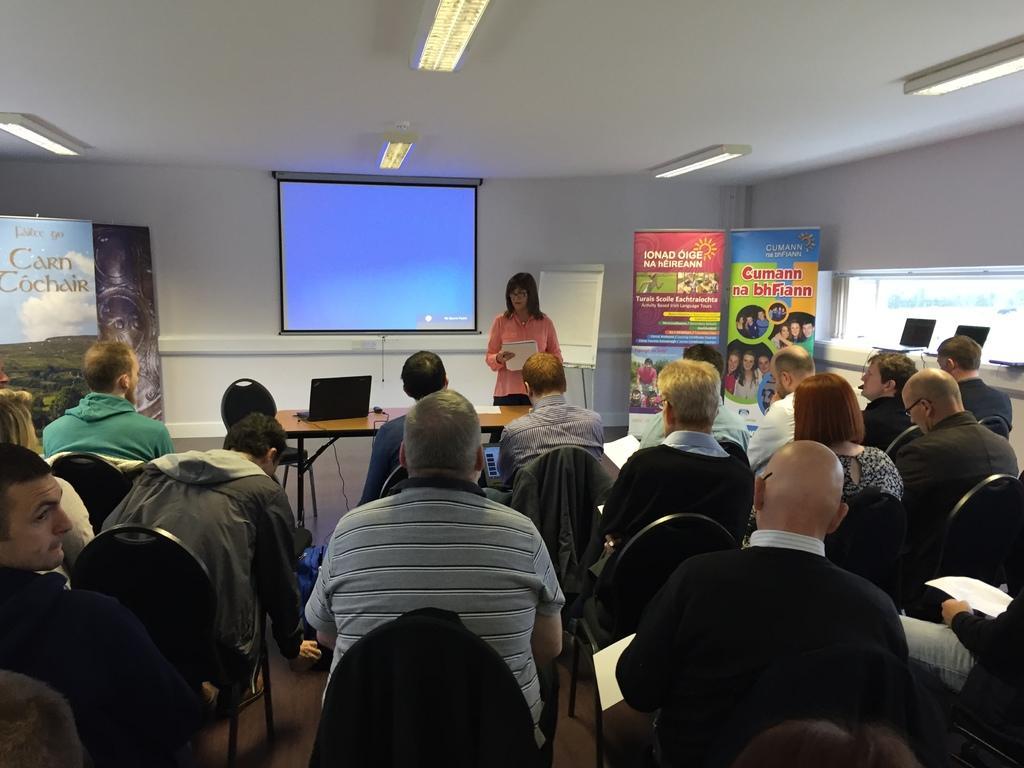How would you summarize this image in a sentence or two? In this picture I can see a group of people are sitting on the chairs in the middle, there are banners on either side of this image. In the background a woman is standing, beside her there is a laptop on the table. Behind her I can see the projector screen, at top there are ceiling lights. 